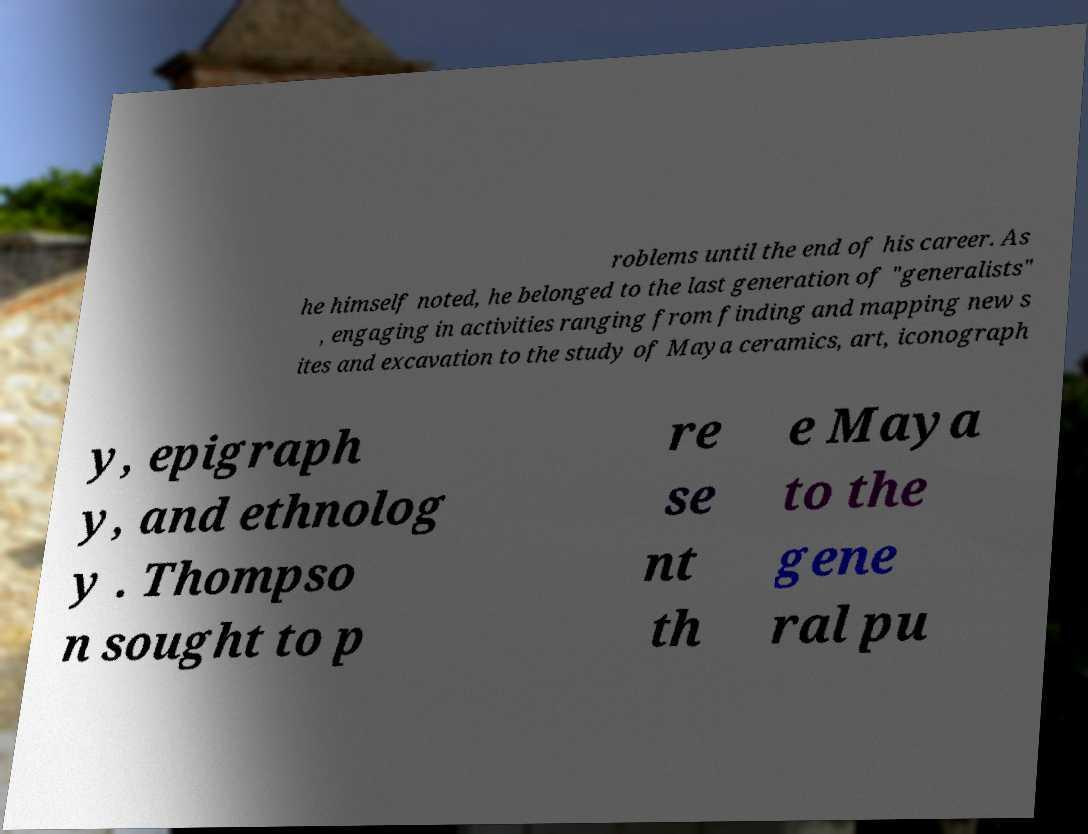What messages or text are displayed in this image? I need them in a readable, typed format. roblems until the end of his career. As he himself noted, he belonged to the last generation of "generalists" , engaging in activities ranging from finding and mapping new s ites and excavation to the study of Maya ceramics, art, iconograph y, epigraph y, and ethnolog y . Thompso n sought to p re se nt th e Maya to the gene ral pu 